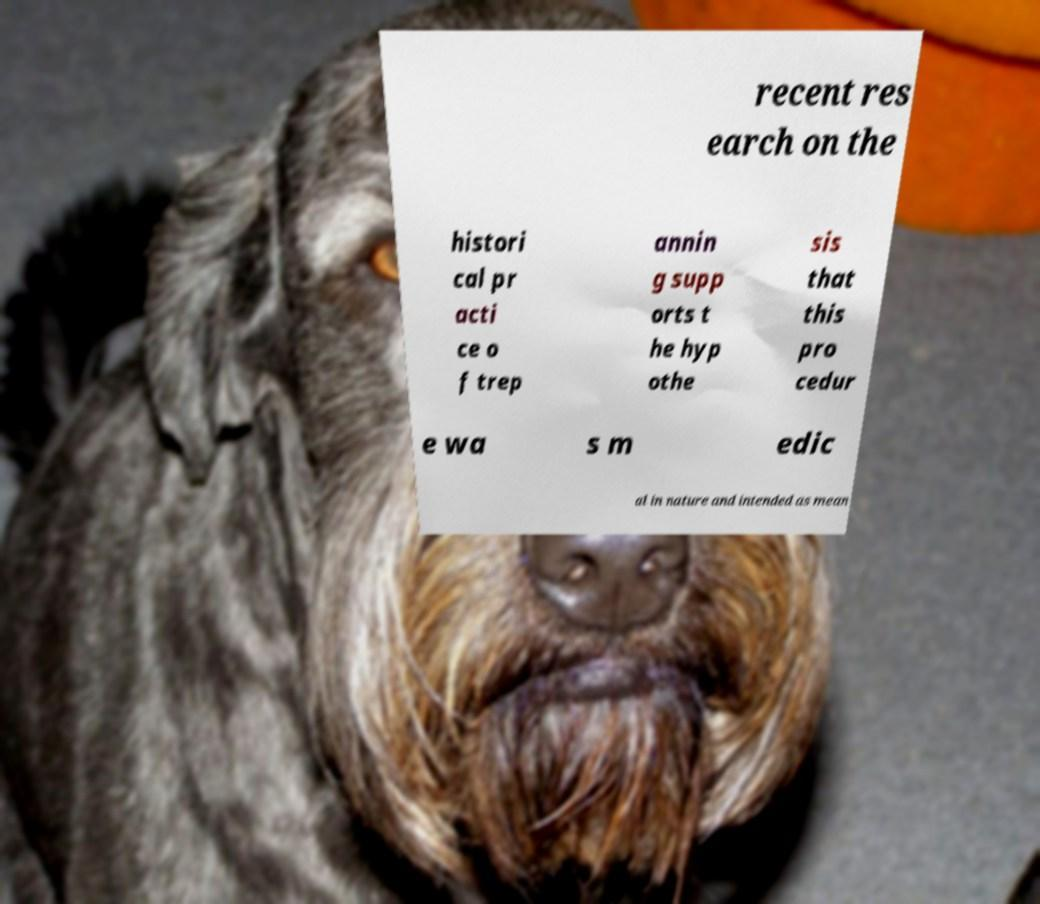Please read and relay the text visible in this image. What does it say? recent res earch on the histori cal pr acti ce o f trep annin g supp orts t he hyp othe sis that this pro cedur e wa s m edic al in nature and intended as mean 